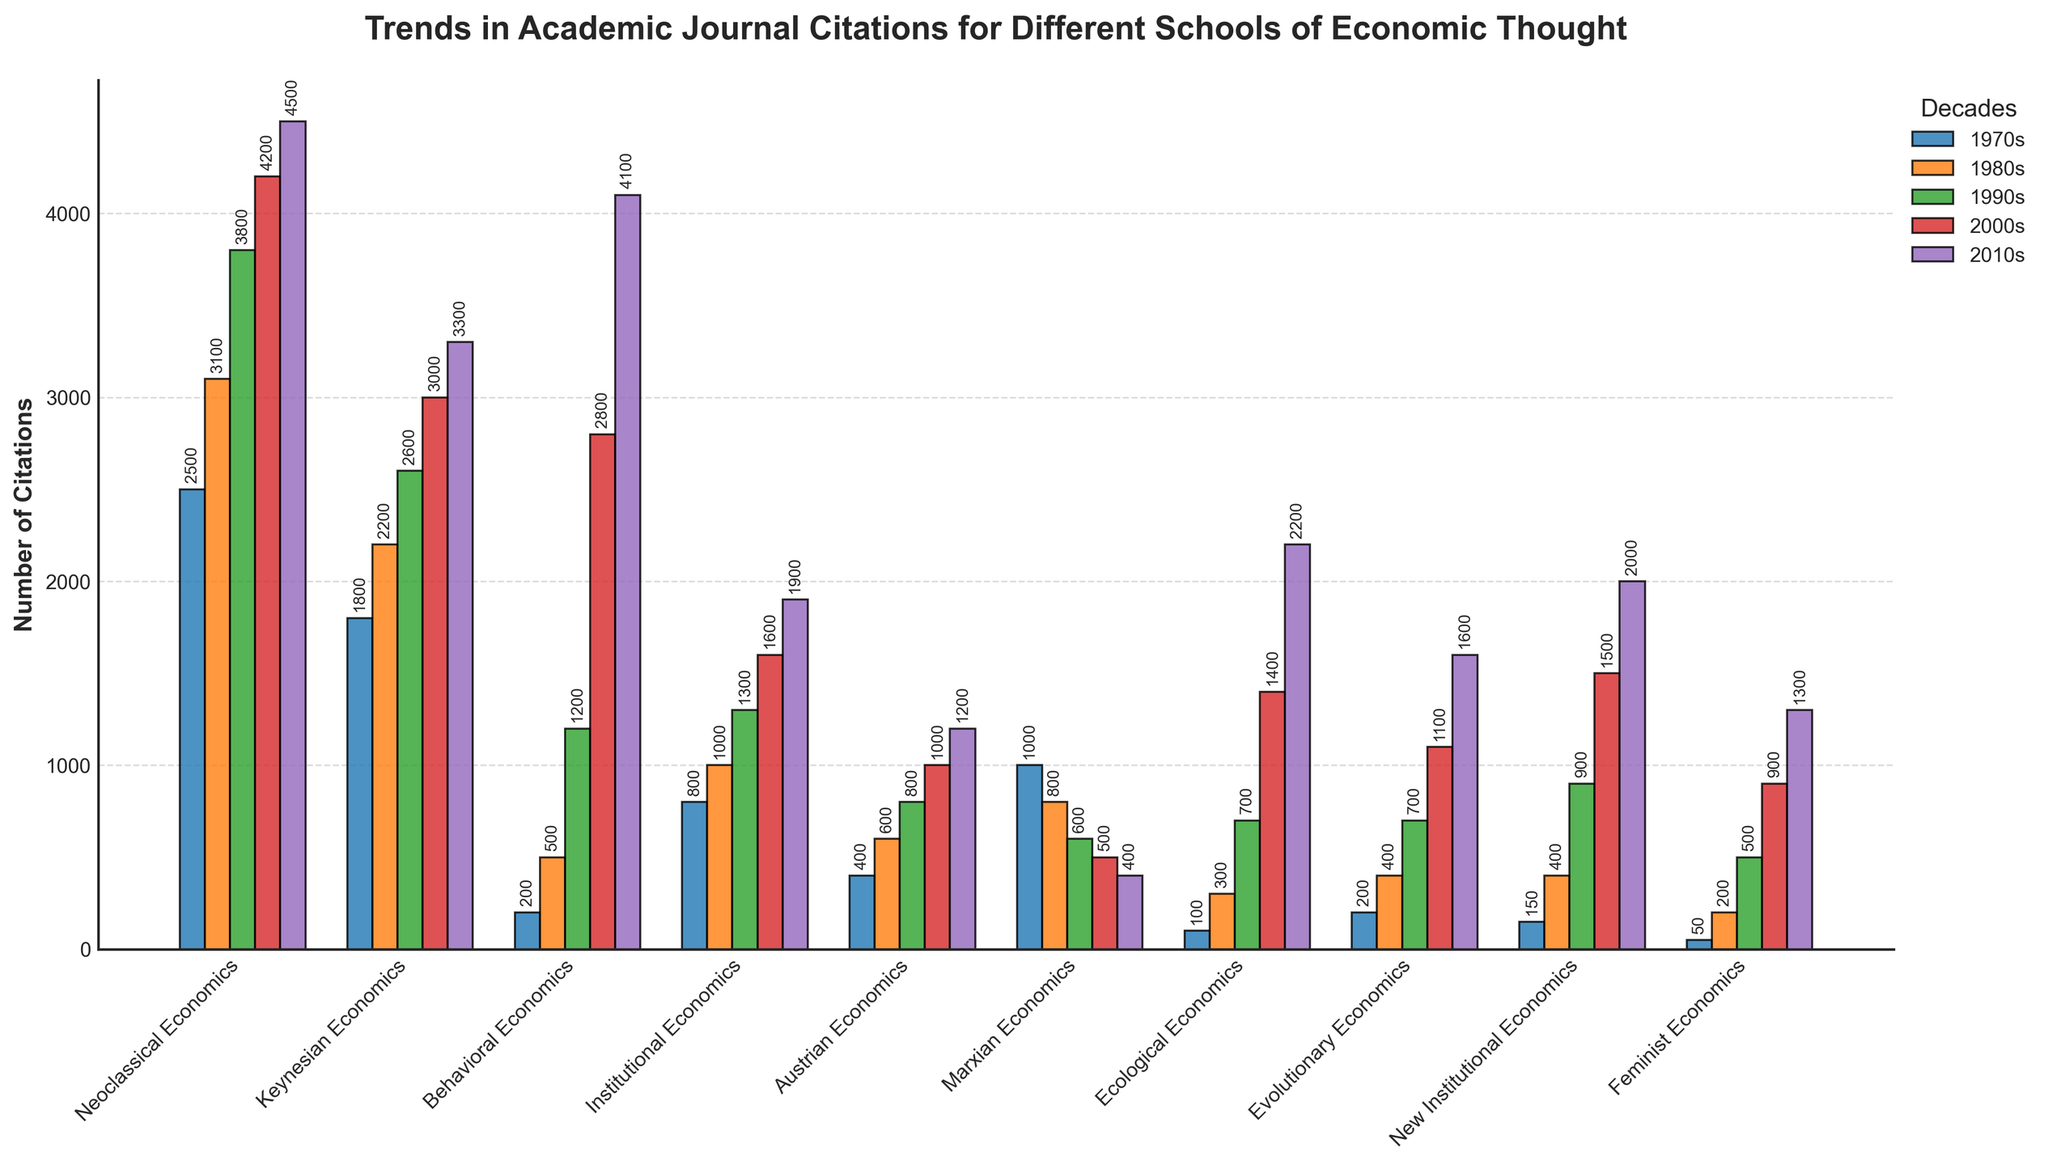Which school of thought saw the highest number of citations in the 2000s? By looking at the chart, find the tallest bar in the 2000s category. The tallest bar represents Neoclassical Economics.
Answer: Neoclassical Economics How did the number of citations for Keynesian Economics change from the 1970s to the 2010s? Find the bars representing Keynesian Economics in both the 1970s and the 2010s and note their heights. Subtract the 1970s value from the 2010s value: 3300 - 1800.
Answer: Increased by 1500 Between Behavioral Economics and Ecological Economics, which had a greater increase in citations from the 1980s to the 2010s? Calculate the increase for both schools between the 1980s and the 2010s: Behavioral Economics (4100 - 500) = 3600, Ecological Economics (2200 - 300) = 1900. Compare the two results.
Answer: Behavioral Economics What is the average number of citations for Austrian Economics and Feminist Economics in the 2010s? Find the heights of the bars for Austrian Economics and Feminist Economics in the 2010s, add the values and divide by 2: (1200 + 1300) / 2.
Answer: 1250 Which school of thought saw a continual decrease in citations over the decades? Check all the bars for each school across the decades to see if there is a consistent decline. Marxian Economics shows a steady decline: 1000, 800, 600, 500, 400.
Answer: Marxian Economics What is the sum of citations for Institutional Economics across all decades? Add up the heights of the bars for Institutional Economics across all decades: 800 + 1000 + 1300 + 1600 + 1900.
Answer: 6600 Which school of thought had the least citations in the 1970s? Identify the shortest bar in the 1970s category. The shortest bar represents Feminist Economics.
Answer: Feminist Economics What is the difference in citations between Behavioral Economics and New Institutional Economics in the 2000s? Find the heights of the bars for Behavioral Economics and New Institutional Economics in the 2000s and subtract the smaller from the larger: 2800 - 1500.
Answer: 1300 In which decade did Behavioral Economics first surpass 1000 citations? Find the decade where the bar height for Behavioral Economics first exceeds 1000. This happens in the 1990s.
Answer: 1990s Which school of thought saw more citations in the 1980s: Austrian Economics or Institutional Economics? Compare the heights of the bars for Austrian Economics and Institutional Economics in the 1980s. Institutional Economics (1000) is taller than Austrian Economics (600).
Answer: Institutional Economics 